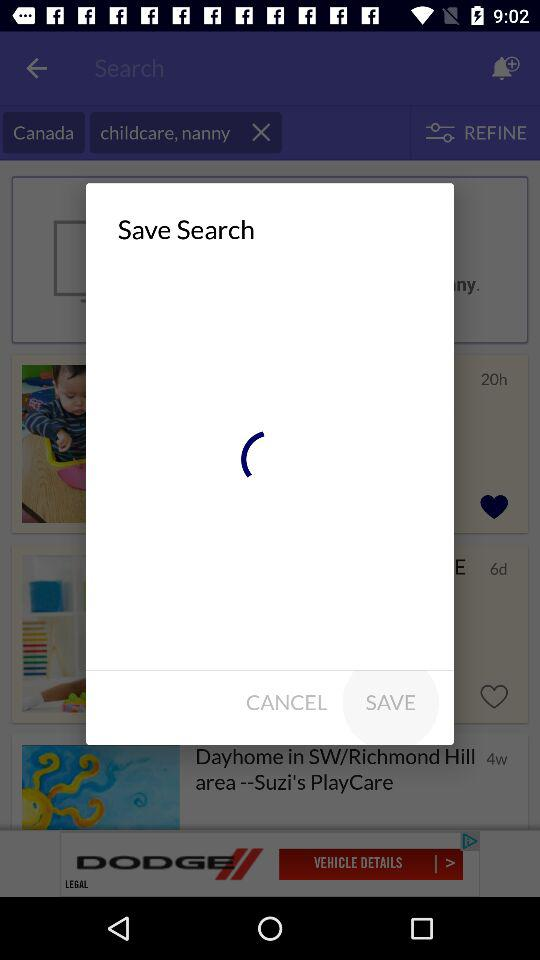How many pets in total are there? There are 130,791 pets. 